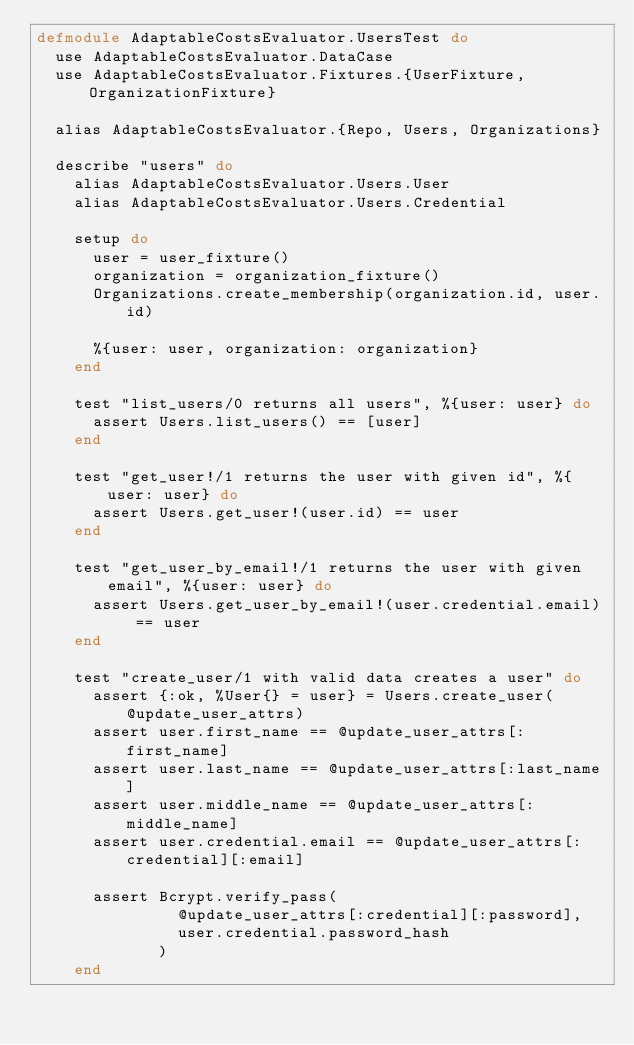<code> <loc_0><loc_0><loc_500><loc_500><_Elixir_>defmodule AdaptableCostsEvaluator.UsersTest do
  use AdaptableCostsEvaluator.DataCase
  use AdaptableCostsEvaluator.Fixtures.{UserFixture, OrganizationFixture}

  alias AdaptableCostsEvaluator.{Repo, Users, Organizations}

  describe "users" do
    alias AdaptableCostsEvaluator.Users.User
    alias AdaptableCostsEvaluator.Users.Credential

    setup do
      user = user_fixture()
      organization = organization_fixture()
      Organizations.create_membership(organization.id, user.id)

      %{user: user, organization: organization}
    end

    test "list_users/0 returns all users", %{user: user} do
      assert Users.list_users() == [user]
    end

    test "get_user!/1 returns the user with given id", %{user: user} do
      assert Users.get_user!(user.id) == user
    end

    test "get_user_by_email!/1 returns the user with given email", %{user: user} do
      assert Users.get_user_by_email!(user.credential.email) == user
    end

    test "create_user/1 with valid data creates a user" do
      assert {:ok, %User{} = user} = Users.create_user(@update_user_attrs)
      assert user.first_name == @update_user_attrs[:first_name]
      assert user.last_name == @update_user_attrs[:last_name]
      assert user.middle_name == @update_user_attrs[:middle_name]
      assert user.credential.email == @update_user_attrs[:credential][:email]

      assert Bcrypt.verify_pass(
               @update_user_attrs[:credential][:password],
               user.credential.password_hash
             )
    end
</code> 